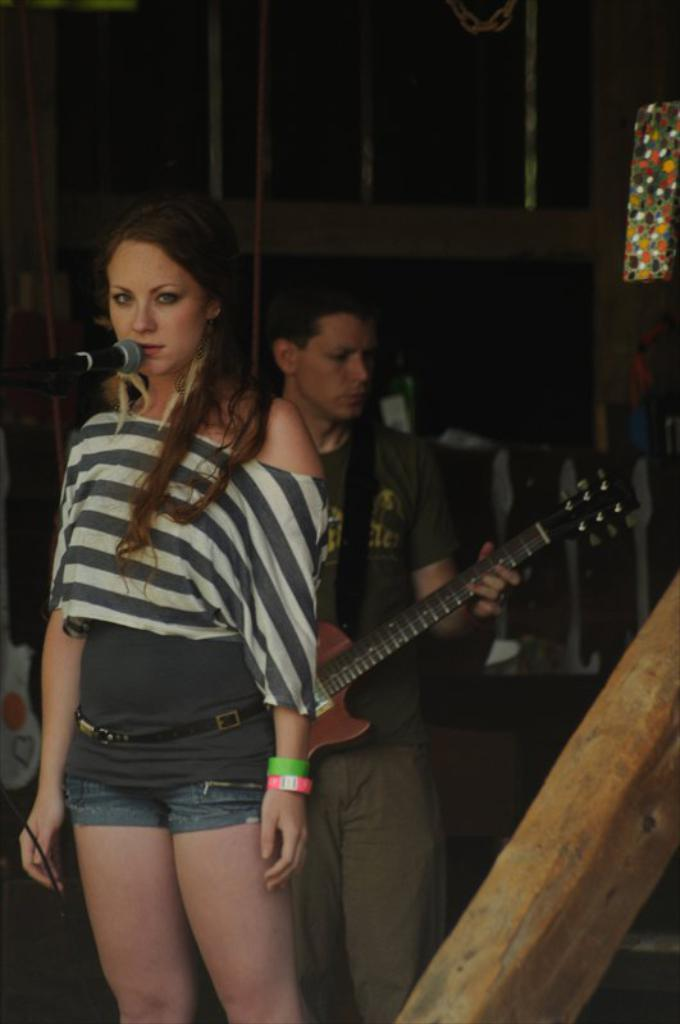How many people are in the image? There are two persons in the image. What is the woman in the front of the image doing? The woman is singing in the front of the image. What is the woman holding while singing? The woman is holding a microphone. What is the man in the background of the image doing? The man is playing a guitar in the background of the image. What can be seen behind the man and woman? There is a wall in the background of the image. What type of protest is happening in the image? There is no protest present in the image; it features a woman singing and a man playing a guitar. How does the crack in the wall affect the performance in the image? There is no crack in the wall mentioned in the image, so it cannot affect the performance. 